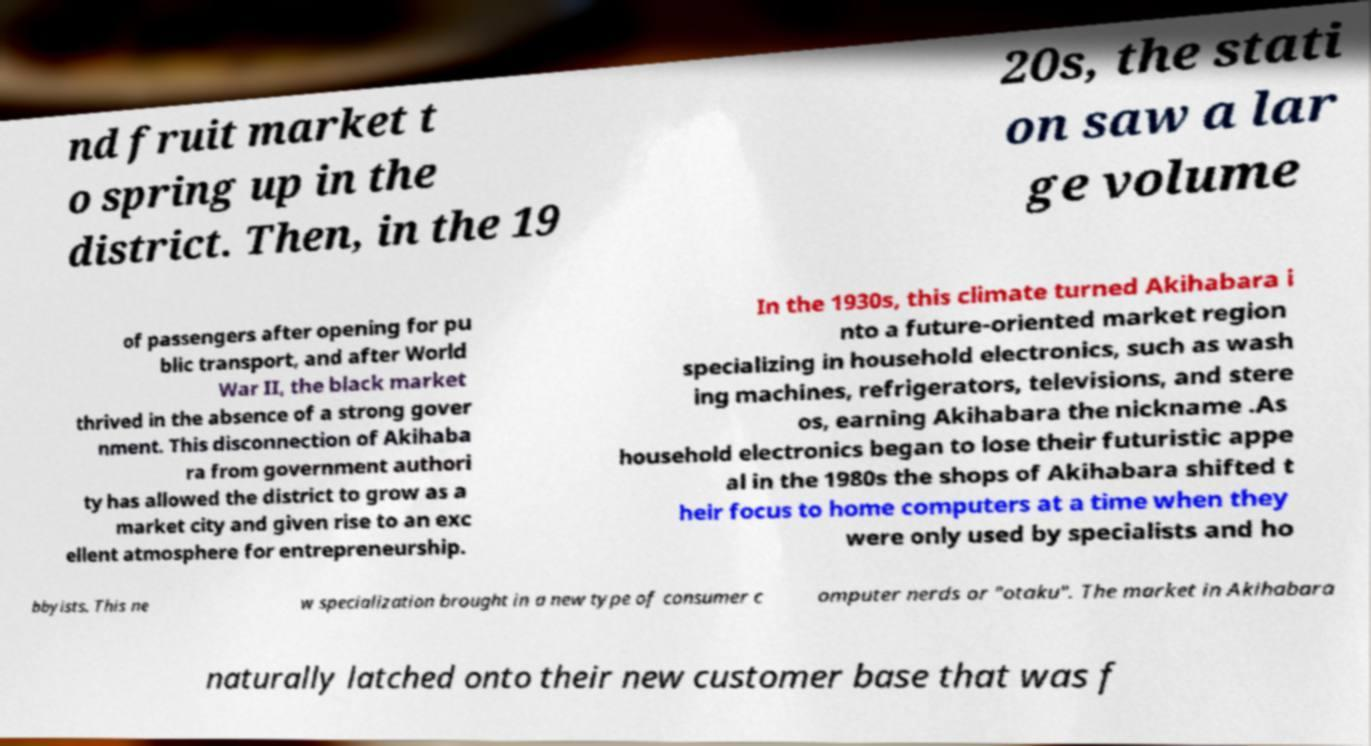What messages or text are displayed in this image? I need them in a readable, typed format. nd fruit market t o spring up in the district. Then, in the 19 20s, the stati on saw a lar ge volume of passengers after opening for pu blic transport, and after World War II, the black market thrived in the absence of a strong gover nment. This disconnection of Akihaba ra from government authori ty has allowed the district to grow as a market city and given rise to an exc ellent atmosphere for entrepreneurship. In the 1930s, this climate turned Akihabara i nto a future-oriented market region specializing in household electronics, such as wash ing machines, refrigerators, televisions, and stere os, earning Akihabara the nickname .As household electronics began to lose their futuristic appe al in the 1980s the shops of Akihabara shifted t heir focus to home computers at a time when they were only used by specialists and ho bbyists. This ne w specialization brought in a new type of consumer c omputer nerds or "otaku". The market in Akihabara naturally latched onto their new customer base that was f 